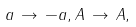Convert formula to latex. <formula><loc_0><loc_0><loc_500><loc_500>a \, \rightarrow \, - a , A \, \rightarrow \, A ,</formula> 